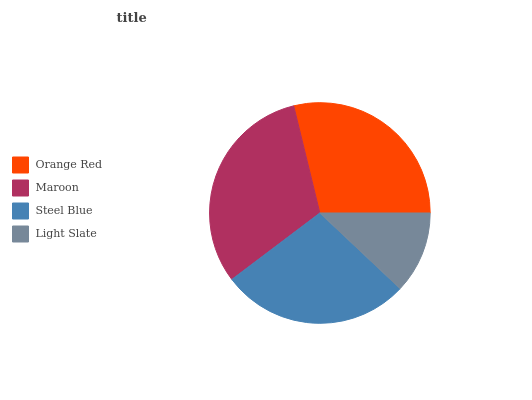Is Light Slate the minimum?
Answer yes or no. Yes. Is Maroon the maximum?
Answer yes or no. Yes. Is Steel Blue the minimum?
Answer yes or no. No. Is Steel Blue the maximum?
Answer yes or no. No. Is Maroon greater than Steel Blue?
Answer yes or no. Yes. Is Steel Blue less than Maroon?
Answer yes or no. Yes. Is Steel Blue greater than Maroon?
Answer yes or no. No. Is Maroon less than Steel Blue?
Answer yes or no. No. Is Orange Red the high median?
Answer yes or no. Yes. Is Steel Blue the low median?
Answer yes or no. Yes. Is Light Slate the high median?
Answer yes or no. No. Is Orange Red the low median?
Answer yes or no. No. 